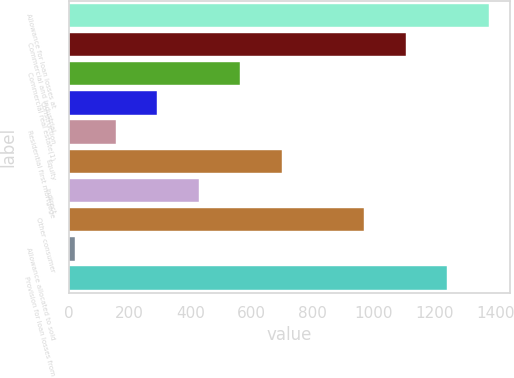Convert chart. <chart><loc_0><loc_0><loc_500><loc_500><bar_chart><fcel>Allowance for loan losses at<fcel>Commercial and industrial<fcel>Commercial real estate(1)<fcel>Construction<fcel>Residential first mortgage<fcel>Equity<fcel>Indirect<fcel>Other consumer<fcel>Allowance allocated to sold<fcel>Provision for loan losses from<nl><fcel>1379<fcel>1107<fcel>563<fcel>291<fcel>155<fcel>699<fcel>427<fcel>971<fcel>19<fcel>1243<nl></chart> 